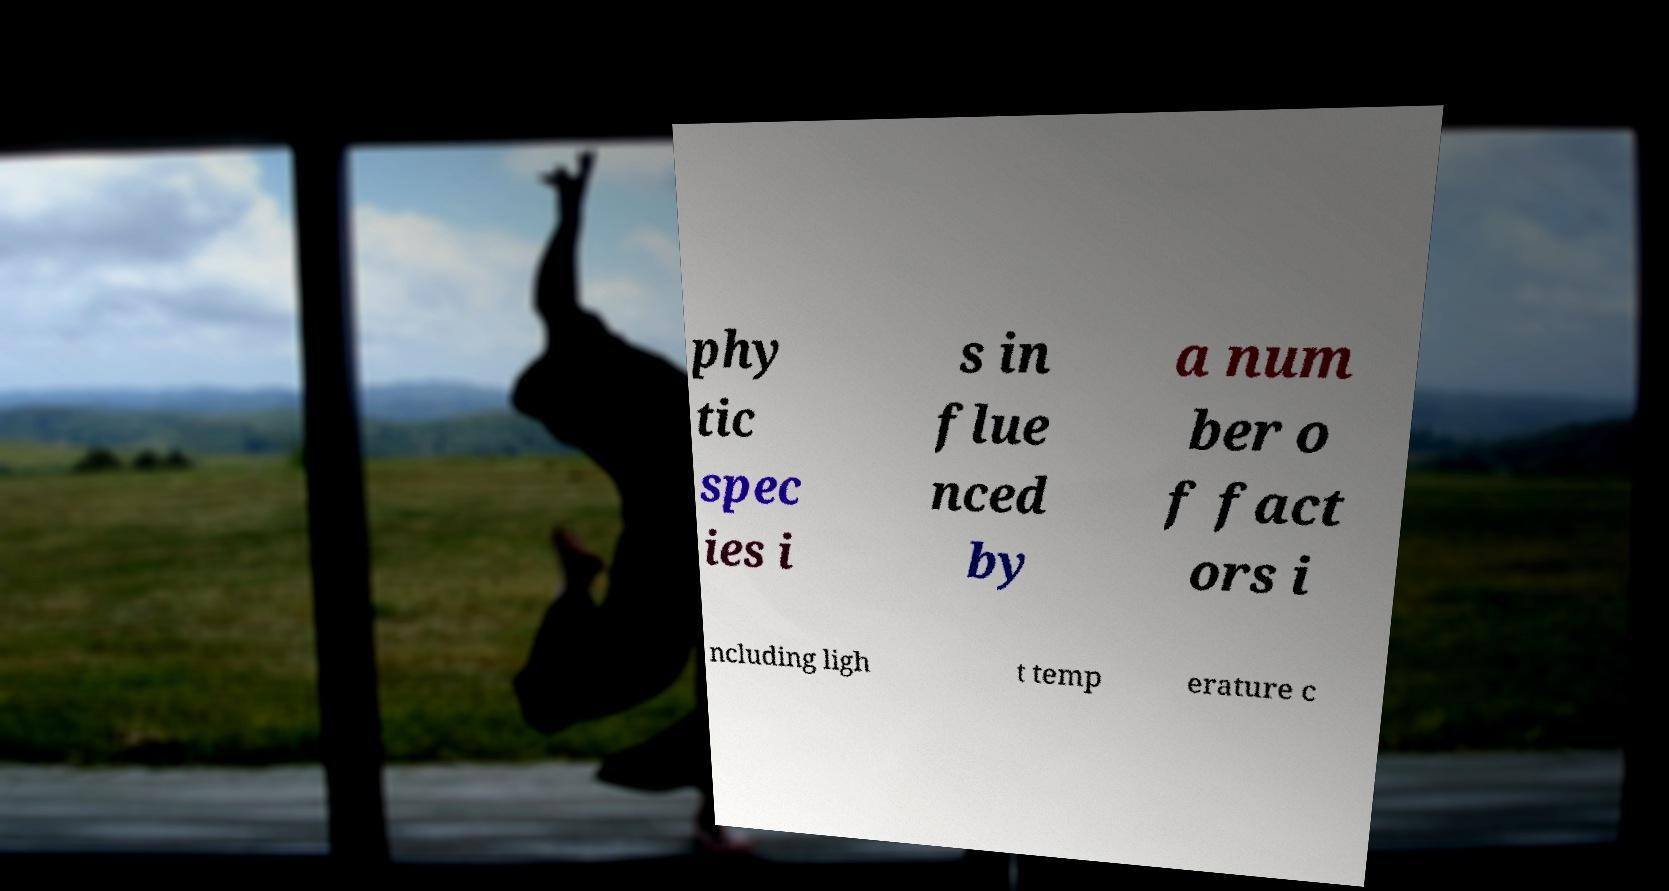Could you extract and type out the text from this image? phy tic spec ies i s in flue nced by a num ber o f fact ors i ncluding ligh t temp erature c 